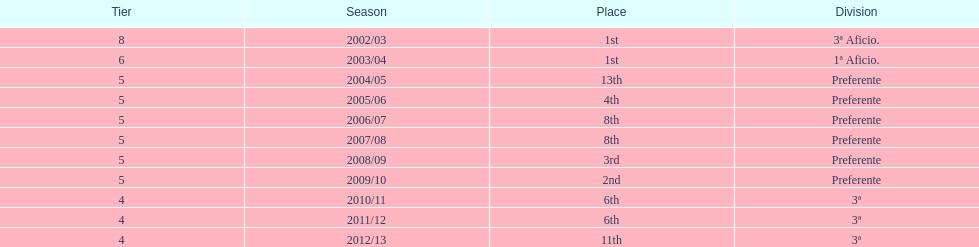What was the number of wins for preferente? 6. 